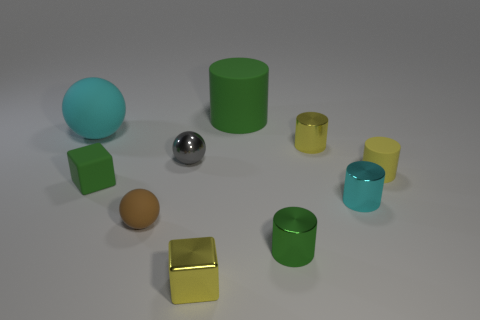Does the green metal thing have the same size as the cyan ball?
Your answer should be very brief. No. What is the color of the big sphere?
Keep it short and to the point. Cyan. What number of tiny cyan things are the same shape as the small green metal thing?
Give a very brief answer. 1. What is the color of the metal sphere that is the same size as the metallic cube?
Your response must be concise. Gray. Is there a cyan cylinder?
Keep it short and to the point. Yes. What shape is the yellow metal thing that is behind the cyan shiny cylinder?
Your answer should be very brief. Cylinder. What number of tiny things are behind the tiny gray metal sphere and on the left side of the gray metal object?
Provide a succinct answer. 0. Are there any tiny cyan things made of the same material as the large green cylinder?
Your response must be concise. No. The matte cylinder that is the same color as the shiny block is what size?
Provide a succinct answer. Small. What number of balls are either large cyan matte things or tiny brown rubber things?
Make the answer very short. 2. 